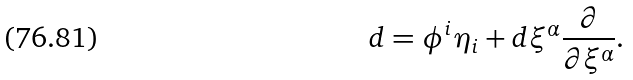Convert formula to latex. <formula><loc_0><loc_0><loc_500><loc_500>d = \phi ^ { i } \eta _ { i } + d \xi ^ { \alpha } \frac { \partial } { \partial \xi ^ { \alpha } } .</formula> 